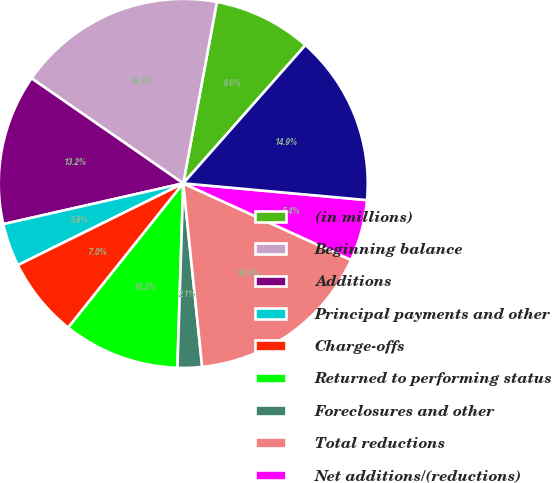<chart> <loc_0><loc_0><loc_500><loc_500><pie_chart><fcel>(in millions)<fcel>Beginning balance<fcel>Additions<fcel>Principal payments and other<fcel>Charge-offs<fcel>Returned to performing status<fcel>Foreclosures and other<fcel>Total reductions<fcel>Net additions/(reductions)<fcel>Ending balance<nl><fcel>8.6%<fcel>18.28%<fcel>13.19%<fcel>3.76%<fcel>6.98%<fcel>10.21%<fcel>2.14%<fcel>16.55%<fcel>5.37%<fcel>14.93%<nl></chart> 